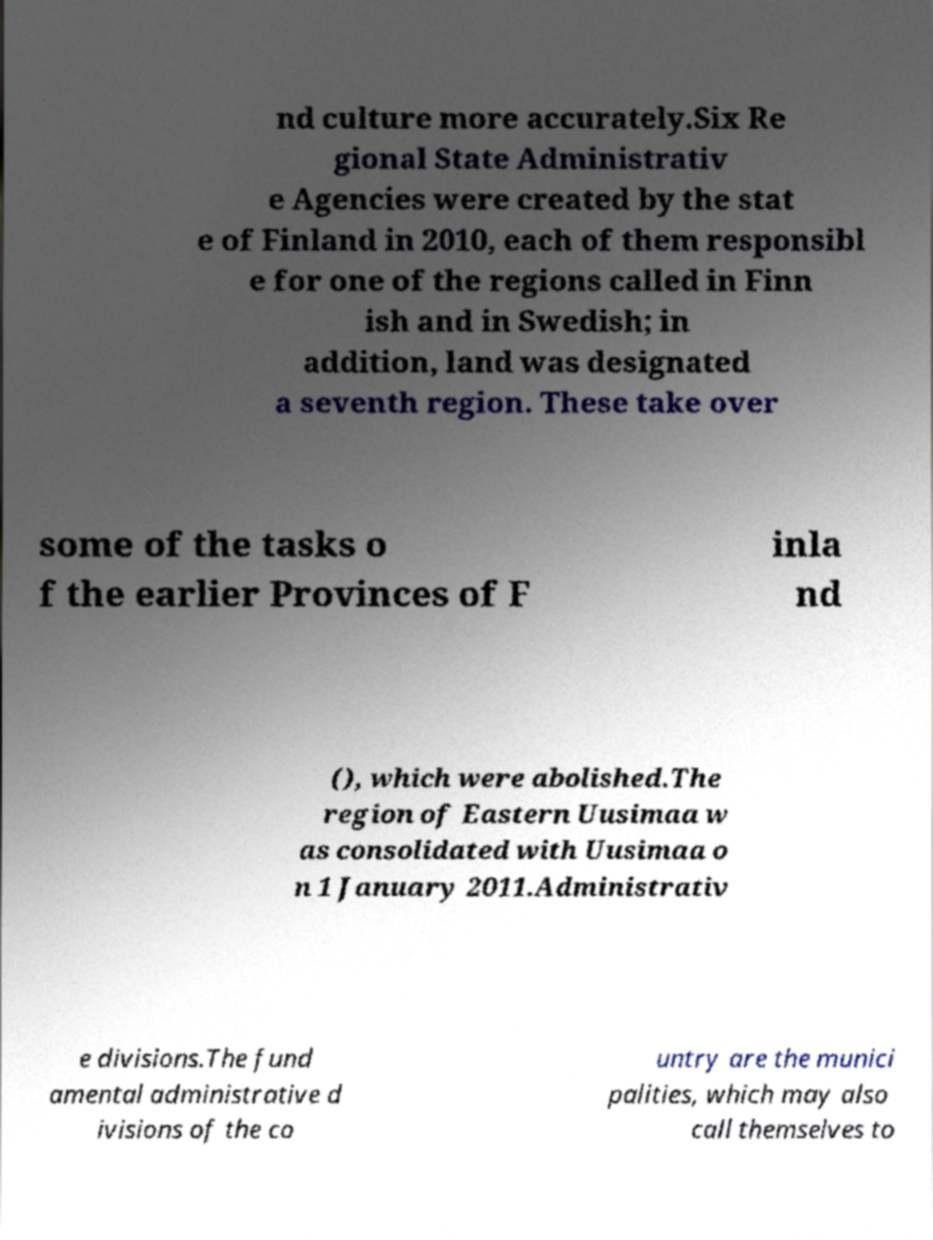Could you extract and type out the text from this image? nd culture more accurately.Six Re gional State Administrativ e Agencies were created by the stat e of Finland in 2010, each of them responsibl e for one of the regions called in Finn ish and in Swedish; in addition, land was designated a seventh region. These take over some of the tasks o f the earlier Provinces of F inla nd (), which were abolished.The region of Eastern Uusimaa w as consolidated with Uusimaa o n 1 January 2011.Administrativ e divisions.The fund amental administrative d ivisions of the co untry are the munici palities, which may also call themselves to 